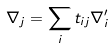Convert formula to latex. <formula><loc_0><loc_0><loc_500><loc_500>\nabla _ { j } = \sum _ { i } t _ { i j } \nabla _ { i } ^ { \prime }</formula> 